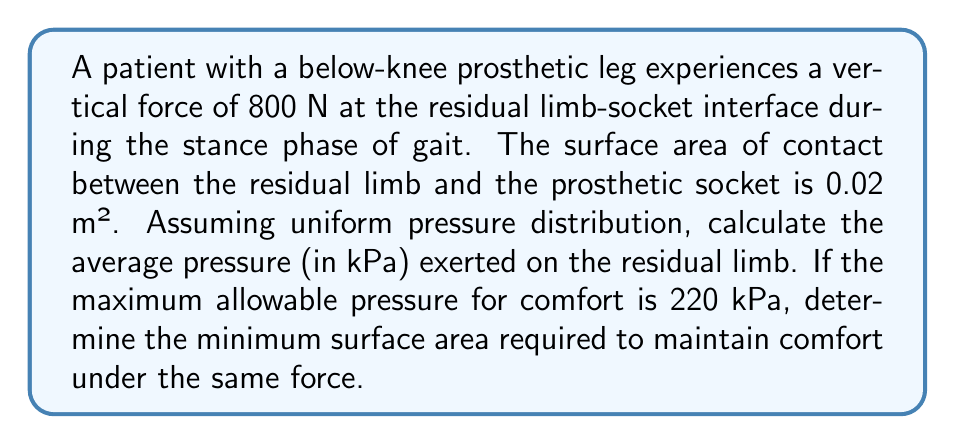Give your solution to this math problem. To solve this problem, we'll use the relationship between pressure, force, and area:

$$P = \frac{F}{A}$$

Where:
$P$ = Pressure (in Pa)
$F$ = Force (in N)
$A$ = Area (in m²)

Step 1: Calculate the average pressure with the given surface area
$$P = \frac{F}{A} = \frac{800 \text{ N}}{0.02 \text{ m}^2} = 40,000 \text{ Pa} = 40 \text{ kPa}$$

Step 2: Determine the minimum surface area required for comfort
Using the maximum allowable pressure of 220 kPa:

$$A_{min} = \frac{F}{P_{max}} = \frac{800 \text{ N}}{220,000 \text{ Pa}} = 0.003636 \text{ m}^2$$

To convert this to cm²:
$$A_{min} = 0.003636 \text{ m}^2 \times 10000 \frac{\text{cm}^2}{\text{m}^2} = 36.36 \text{ cm}^2$$

Therefore, the minimum surface area required to maintain comfort under the same force is approximately 36.36 cm².
Answer: The average pressure exerted on the residual limb is 40 kPa. The minimum surface area required to maintain comfort under the same force is 36.36 cm². 